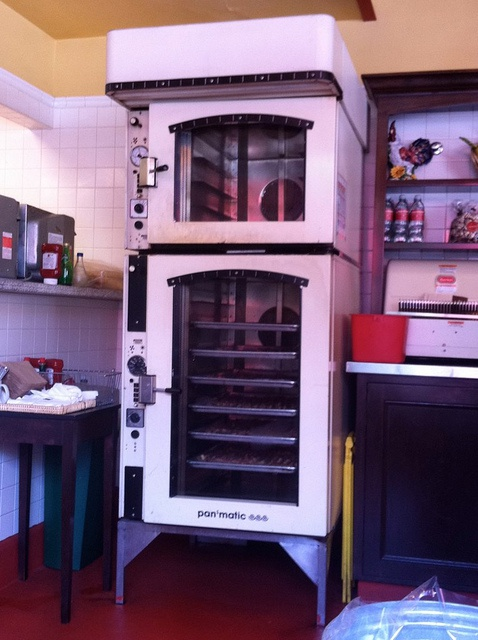Describe the objects in this image and their specific colors. I can see oven in tan, black, lavender, pink, and purple tones, oven in tan, black, pink, and purple tones, bottle in tan, maroon, violet, and black tones, bottle in tan, purple, and violet tones, and bottle in tan, navy, purple, and black tones in this image. 